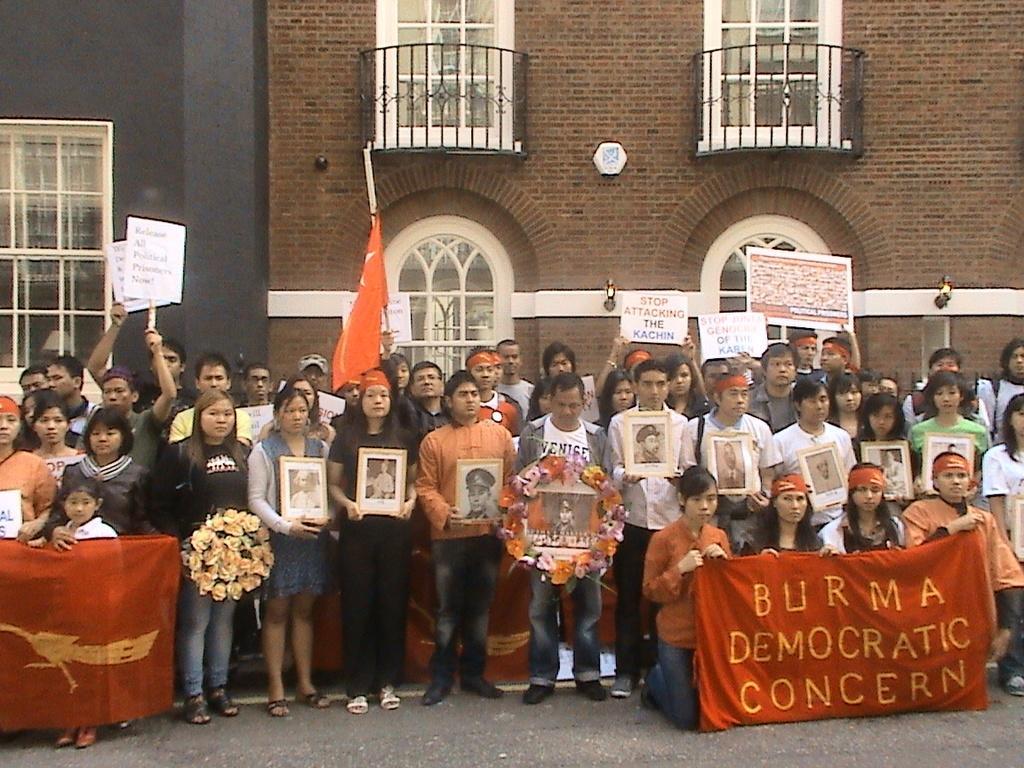Can you describe this image briefly? In this image, we can see people and are holding banners, boards and bouquets. In the background, there is a building and we can see windows and railings. At the bottom, there is a road. 